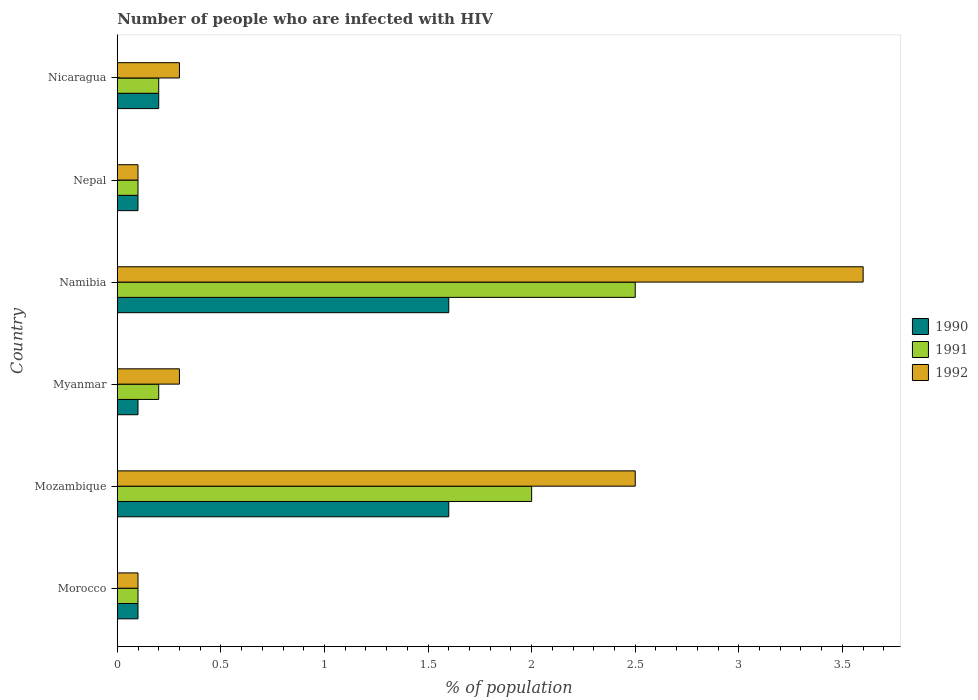How many different coloured bars are there?
Ensure brevity in your answer.  3. How many groups of bars are there?
Your answer should be compact. 6. Are the number of bars per tick equal to the number of legend labels?
Offer a terse response. Yes. How many bars are there on the 5th tick from the top?
Offer a very short reply. 3. How many bars are there on the 5th tick from the bottom?
Ensure brevity in your answer.  3. What is the label of the 6th group of bars from the top?
Make the answer very short. Morocco. In how many cases, is the number of bars for a given country not equal to the number of legend labels?
Offer a very short reply. 0. Across all countries, what is the maximum percentage of HIV infected population in in 1991?
Your answer should be very brief. 2.5. In which country was the percentage of HIV infected population in in 1992 maximum?
Ensure brevity in your answer.  Namibia. In which country was the percentage of HIV infected population in in 1991 minimum?
Provide a succinct answer. Morocco. What is the total percentage of HIV infected population in in 1992 in the graph?
Make the answer very short. 6.9. What is the difference between the percentage of HIV infected population in in 1992 in Myanmar and that in Nepal?
Your answer should be compact. 0.2. What is the difference between the percentage of HIV infected population in in 1991 in Namibia and the percentage of HIV infected population in in 1990 in Nicaragua?
Give a very brief answer. 2.3. What is the average percentage of HIV infected population in in 1990 per country?
Make the answer very short. 0.62. What is the difference between the percentage of HIV infected population in in 1992 and percentage of HIV infected population in in 1990 in Mozambique?
Offer a very short reply. 0.9. What is the ratio of the percentage of HIV infected population in in 1990 in Myanmar to that in Nepal?
Give a very brief answer. 1. Is the sum of the percentage of HIV infected population in in 1992 in Mozambique and Nepal greater than the maximum percentage of HIV infected population in in 1991 across all countries?
Ensure brevity in your answer.  Yes. What does the 1st bar from the top in Nicaragua represents?
Offer a very short reply. 1992. Is it the case that in every country, the sum of the percentage of HIV infected population in in 1992 and percentage of HIV infected population in in 1991 is greater than the percentage of HIV infected population in in 1990?
Your answer should be very brief. Yes. How many bars are there?
Provide a succinct answer. 18. How many countries are there in the graph?
Give a very brief answer. 6. Are the values on the major ticks of X-axis written in scientific E-notation?
Provide a short and direct response. No. Does the graph contain any zero values?
Provide a succinct answer. No. How many legend labels are there?
Ensure brevity in your answer.  3. What is the title of the graph?
Give a very brief answer. Number of people who are infected with HIV. What is the label or title of the X-axis?
Give a very brief answer. % of population. What is the % of population in 1991 in Morocco?
Provide a succinct answer. 0.1. What is the % of population in 1992 in Morocco?
Offer a terse response. 0.1. What is the % of population in 1990 in Mozambique?
Provide a short and direct response. 1.6. What is the % of population in 1992 in Mozambique?
Offer a very short reply. 2.5. What is the % of population of 1990 in Nepal?
Give a very brief answer. 0.1. What is the % of population in 1991 in Nepal?
Your answer should be compact. 0.1. What is the % of population of 1992 in Nepal?
Your answer should be very brief. 0.1. What is the % of population of 1992 in Nicaragua?
Offer a terse response. 0.3. Across all countries, what is the maximum % of population in 1991?
Offer a very short reply. 2.5. Across all countries, what is the maximum % of population of 1992?
Your answer should be compact. 3.6. Across all countries, what is the minimum % of population of 1990?
Give a very brief answer. 0.1. Across all countries, what is the minimum % of population in 1991?
Your answer should be very brief. 0.1. Across all countries, what is the minimum % of population in 1992?
Your answer should be compact. 0.1. What is the total % of population in 1992 in the graph?
Give a very brief answer. 6.9. What is the difference between the % of population of 1990 in Morocco and that in Myanmar?
Your response must be concise. 0. What is the difference between the % of population in 1991 in Morocco and that in Myanmar?
Keep it short and to the point. -0.1. What is the difference between the % of population of 1990 in Morocco and that in Namibia?
Your answer should be very brief. -1.5. What is the difference between the % of population of 1992 in Morocco and that in Namibia?
Ensure brevity in your answer.  -3.5. What is the difference between the % of population of 1991 in Morocco and that in Nepal?
Provide a succinct answer. 0. What is the difference between the % of population in 1992 in Morocco and that in Nepal?
Offer a terse response. 0. What is the difference between the % of population of 1991 in Morocco and that in Nicaragua?
Offer a terse response. -0.1. What is the difference between the % of population in 1992 in Morocco and that in Nicaragua?
Keep it short and to the point. -0.2. What is the difference between the % of population in 1991 in Mozambique and that in Myanmar?
Make the answer very short. 1.8. What is the difference between the % of population in 1990 in Mozambique and that in Namibia?
Offer a terse response. 0. What is the difference between the % of population in 1992 in Mozambique and that in Namibia?
Your answer should be compact. -1.1. What is the difference between the % of population of 1991 in Mozambique and that in Nicaragua?
Your answer should be very brief. 1.8. What is the difference between the % of population of 1992 in Mozambique and that in Nicaragua?
Offer a very short reply. 2.2. What is the difference between the % of population in 1990 in Myanmar and that in Namibia?
Offer a terse response. -1.5. What is the difference between the % of population in 1991 in Myanmar and that in Namibia?
Your response must be concise. -2.3. What is the difference between the % of population of 1992 in Myanmar and that in Namibia?
Offer a very short reply. -3.3. What is the difference between the % of population of 1991 in Myanmar and that in Nepal?
Your answer should be very brief. 0.1. What is the difference between the % of population of 1992 in Myanmar and that in Nepal?
Ensure brevity in your answer.  0.2. What is the difference between the % of population of 1990 in Myanmar and that in Nicaragua?
Your answer should be compact. -0.1. What is the difference between the % of population in 1991 in Myanmar and that in Nicaragua?
Ensure brevity in your answer.  0. What is the difference between the % of population of 1990 in Namibia and that in Nepal?
Provide a succinct answer. 1.5. What is the difference between the % of population of 1992 in Namibia and that in Nepal?
Your answer should be compact. 3.5. What is the difference between the % of population in 1991 in Namibia and that in Nicaragua?
Make the answer very short. 2.3. What is the difference between the % of population of 1990 in Morocco and the % of population of 1991 in Mozambique?
Offer a very short reply. -1.9. What is the difference between the % of population in 1990 in Morocco and the % of population in 1992 in Mozambique?
Keep it short and to the point. -2.4. What is the difference between the % of population of 1990 in Morocco and the % of population of 1991 in Myanmar?
Provide a short and direct response. -0.1. What is the difference between the % of population of 1991 in Morocco and the % of population of 1992 in Myanmar?
Provide a short and direct response. -0.2. What is the difference between the % of population of 1990 in Morocco and the % of population of 1991 in Nepal?
Your answer should be very brief. 0. What is the difference between the % of population in 1990 in Morocco and the % of population in 1992 in Nepal?
Your response must be concise. 0. What is the difference between the % of population of 1991 in Morocco and the % of population of 1992 in Nepal?
Your answer should be very brief. 0. What is the difference between the % of population in 1990 in Morocco and the % of population in 1992 in Nicaragua?
Your answer should be very brief. -0.2. What is the difference between the % of population of 1990 in Mozambique and the % of population of 1991 in Myanmar?
Your answer should be compact. 1.4. What is the difference between the % of population in 1990 in Mozambique and the % of population in 1991 in Namibia?
Your response must be concise. -0.9. What is the difference between the % of population in 1990 in Mozambique and the % of population in 1992 in Namibia?
Keep it short and to the point. -2. What is the difference between the % of population of 1991 in Mozambique and the % of population of 1992 in Namibia?
Your response must be concise. -1.6. What is the difference between the % of population in 1990 in Mozambique and the % of population in 1991 in Nepal?
Offer a terse response. 1.5. What is the difference between the % of population of 1990 in Mozambique and the % of population of 1992 in Nepal?
Keep it short and to the point. 1.5. What is the difference between the % of population in 1990 in Myanmar and the % of population in 1991 in Namibia?
Offer a very short reply. -2.4. What is the difference between the % of population of 1990 in Myanmar and the % of population of 1992 in Namibia?
Ensure brevity in your answer.  -3.5. What is the difference between the % of population of 1990 in Myanmar and the % of population of 1992 in Nepal?
Offer a terse response. 0. What is the difference between the % of population in 1990 in Myanmar and the % of population in 1991 in Nicaragua?
Ensure brevity in your answer.  -0.1. What is the difference between the % of population in 1990 in Namibia and the % of population in 1992 in Nepal?
Offer a very short reply. 1.5. What is the difference between the % of population in 1991 in Namibia and the % of population in 1992 in Nepal?
Keep it short and to the point. 2.4. What is the difference between the % of population in 1990 in Namibia and the % of population in 1991 in Nicaragua?
Offer a terse response. 1.4. What is the difference between the % of population of 1990 in Namibia and the % of population of 1992 in Nicaragua?
Make the answer very short. 1.3. What is the difference between the % of population of 1990 in Nepal and the % of population of 1991 in Nicaragua?
Offer a very short reply. -0.1. What is the difference between the % of population of 1990 in Nepal and the % of population of 1992 in Nicaragua?
Provide a short and direct response. -0.2. What is the difference between the % of population of 1991 in Nepal and the % of population of 1992 in Nicaragua?
Provide a short and direct response. -0.2. What is the average % of population of 1990 per country?
Give a very brief answer. 0.62. What is the average % of population in 1992 per country?
Your answer should be very brief. 1.15. What is the difference between the % of population in 1990 and % of population in 1992 in Morocco?
Your response must be concise. 0. What is the difference between the % of population in 1990 and % of population in 1991 in Mozambique?
Keep it short and to the point. -0.4. What is the difference between the % of population in 1990 and % of population in 1992 in Mozambique?
Your answer should be very brief. -0.9. What is the difference between the % of population in 1990 and % of population in 1992 in Namibia?
Your response must be concise. -2. What is the difference between the % of population of 1991 and % of population of 1992 in Namibia?
Provide a short and direct response. -1.1. What is the difference between the % of population in 1990 and % of population in 1991 in Nepal?
Offer a terse response. 0. What is the difference between the % of population of 1991 and % of population of 1992 in Nepal?
Your answer should be compact. 0. What is the difference between the % of population in 1990 and % of population in 1992 in Nicaragua?
Your answer should be very brief. -0.1. What is the difference between the % of population of 1991 and % of population of 1992 in Nicaragua?
Your answer should be very brief. -0.1. What is the ratio of the % of population of 1990 in Morocco to that in Mozambique?
Provide a short and direct response. 0.06. What is the ratio of the % of population of 1991 in Morocco to that in Mozambique?
Your response must be concise. 0.05. What is the ratio of the % of population of 1992 in Morocco to that in Mozambique?
Offer a terse response. 0.04. What is the ratio of the % of population in 1990 in Morocco to that in Myanmar?
Give a very brief answer. 1. What is the ratio of the % of population of 1991 in Morocco to that in Myanmar?
Ensure brevity in your answer.  0.5. What is the ratio of the % of population of 1990 in Morocco to that in Namibia?
Give a very brief answer. 0.06. What is the ratio of the % of population in 1992 in Morocco to that in Namibia?
Offer a terse response. 0.03. What is the ratio of the % of population in 1990 in Morocco to that in Nepal?
Provide a succinct answer. 1. What is the ratio of the % of population of 1992 in Morocco to that in Nepal?
Give a very brief answer. 1. What is the ratio of the % of population in 1991 in Morocco to that in Nicaragua?
Offer a terse response. 0.5. What is the ratio of the % of population of 1992 in Morocco to that in Nicaragua?
Provide a succinct answer. 0.33. What is the ratio of the % of population in 1990 in Mozambique to that in Myanmar?
Offer a very short reply. 16. What is the ratio of the % of population in 1992 in Mozambique to that in Myanmar?
Keep it short and to the point. 8.33. What is the ratio of the % of population in 1990 in Mozambique to that in Namibia?
Make the answer very short. 1. What is the ratio of the % of population of 1991 in Mozambique to that in Namibia?
Give a very brief answer. 0.8. What is the ratio of the % of population in 1992 in Mozambique to that in Namibia?
Provide a succinct answer. 0.69. What is the ratio of the % of population in 1990 in Mozambique to that in Nepal?
Make the answer very short. 16. What is the ratio of the % of population in 1991 in Mozambique to that in Nepal?
Offer a very short reply. 20. What is the ratio of the % of population in 1992 in Mozambique to that in Nepal?
Your answer should be very brief. 25. What is the ratio of the % of population of 1992 in Mozambique to that in Nicaragua?
Provide a succinct answer. 8.33. What is the ratio of the % of population of 1990 in Myanmar to that in Namibia?
Ensure brevity in your answer.  0.06. What is the ratio of the % of population of 1992 in Myanmar to that in Namibia?
Your answer should be very brief. 0.08. What is the ratio of the % of population of 1990 in Myanmar to that in Nepal?
Give a very brief answer. 1. What is the ratio of the % of population in 1992 in Myanmar to that in Nepal?
Provide a short and direct response. 3. What is the ratio of the % of population of 1990 in Myanmar to that in Nicaragua?
Provide a short and direct response. 0.5. What is the ratio of the % of population in 1991 in Myanmar to that in Nicaragua?
Your response must be concise. 1. What is the ratio of the % of population in 1992 in Myanmar to that in Nicaragua?
Keep it short and to the point. 1. What is the ratio of the % of population in 1990 in Namibia to that in Nepal?
Make the answer very short. 16. What is the ratio of the % of population of 1991 in Namibia to that in Nepal?
Keep it short and to the point. 25. What is the ratio of the % of population in 1992 in Namibia to that in Nepal?
Provide a succinct answer. 36. What is the ratio of the % of population in 1991 in Namibia to that in Nicaragua?
Your answer should be very brief. 12.5. What is the ratio of the % of population in 1992 in Namibia to that in Nicaragua?
Offer a very short reply. 12. What is the ratio of the % of population in 1990 in Nepal to that in Nicaragua?
Offer a terse response. 0.5. What is the ratio of the % of population of 1991 in Nepal to that in Nicaragua?
Offer a terse response. 0.5. What is the difference between the highest and the second highest % of population of 1990?
Keep it short and to the point. 0. What is the difference between the highest and the second highest % of population of 1991?
Give a very brief answer. 0.5. What is the difference between the highest and the lowest % of population of 1990?
Keep it short and to the point. 1.5. What is the difference between the highest and the lowest % of population in 1992?
Your answer should be very brief. 3.5. 